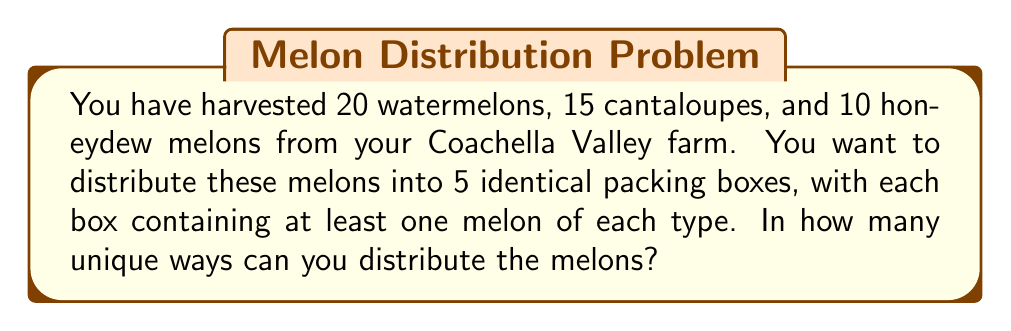Could you help me with this problem? Let's approach this step-by-step using the stars and bars method:

1) First, we need to distribute the watermelons. We have 20 watermelons and 5 boxes. This is equivalent to placing 19 dividers among 20 stars. The number of ways to do this is:

   $$\binom{20 + 5 - 1}{5 - 1} = \binom{24}{4}$$

2) For cantaloupes, we have 15 melons and 5 boxes. Similarly:

   $$\binom{15 + 5 - 1}{5 - 1} = \binom{19}{4}$$

3) For honeydew melons, we have 10 melons and 5 boxes:

   $$\binom{10 + 5 - 1}{5 - 1} = \binom{14}{4}$$

4) However, we need to ensure that each box has at least one of each type of melon. To do this, we can first distribute one of each type to each box, and then distribute the remaining melons:

   Remaining watermelons: 20 - 5 = 15
   Remaining cantaloupes: 15 - 5 = 10
   Remaining honeydew: 10 - 5 = 5

5) Now we can apply the stars and bars method to these remaining melons:

   Watermelons: $$\binom{15 + 5 - 1}{5 - 1} = \binom{19}{4}$$
   Cantaloupes: $$\binom{10 + 5 - 1}{5 - 1} = \binom{14}{4}$$
   Honeydew: $$\binom{5 + 5 - 1}{5 - 1} = \binom{9}{4}$$

6) By the multiplication principle, the total number of ways to distribute the melons is:

   $$\binom{19}{4} \times \binom{14}{4} \times \binom{9}{4}$$

7) Calculating this:
   $$\binom{19}{4} = 3876$$
   $$\binom{14}{4} = 1001$$
   $$\binom{9}{4} = 126$$

   $$3876 \times 1001 \times 126 = 488,347,876$$
Answer: 488,347,876 